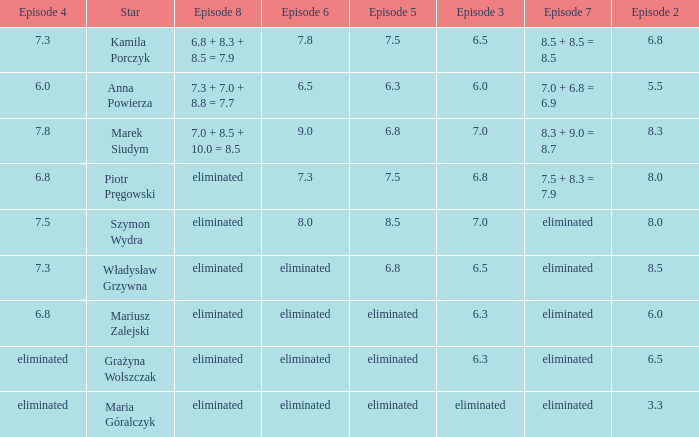Which episode 4 has a Star of anna powierza? 6.0. 